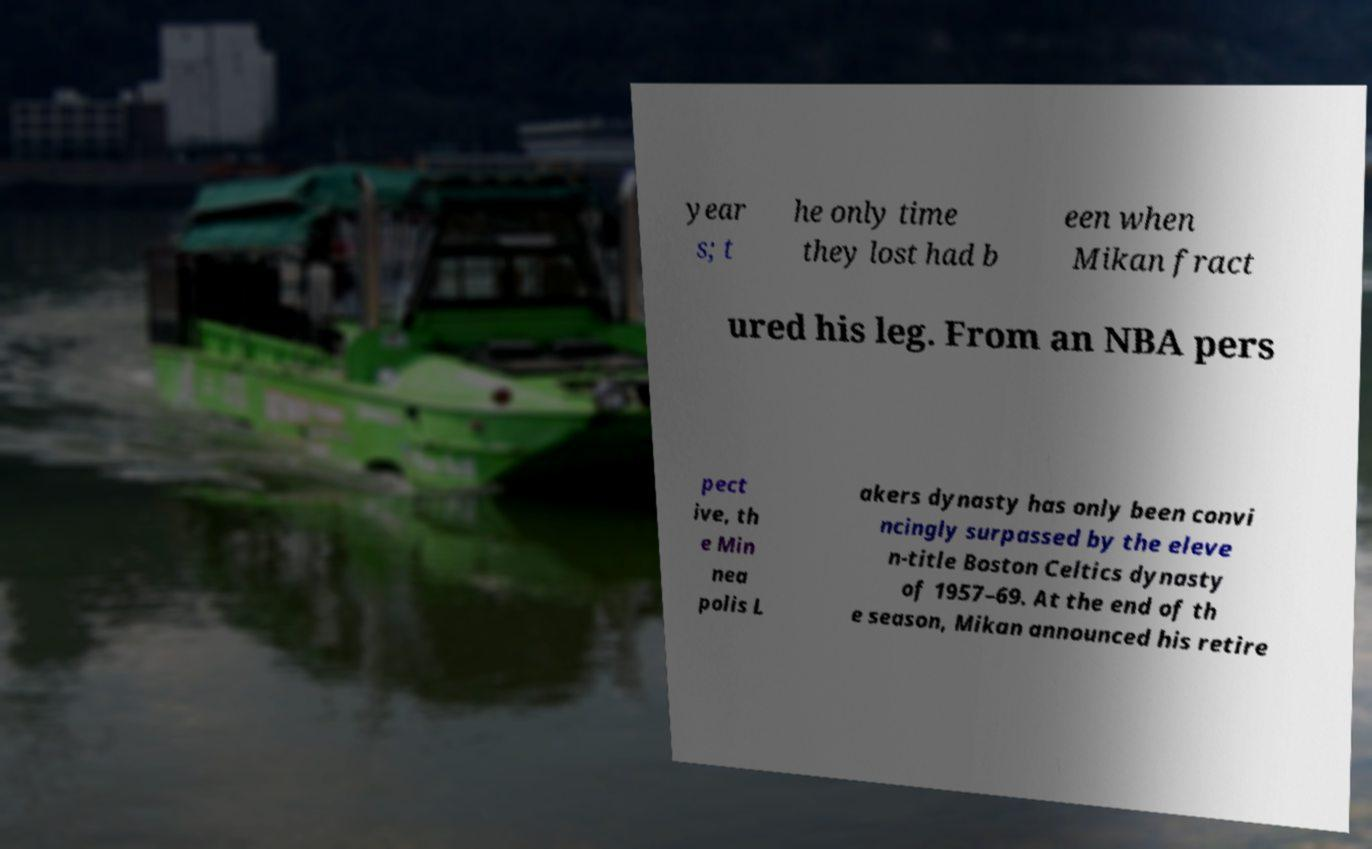Please read and relay the text visible in this image. What does it say? year s; t he only time they lost had b een when Mikan fract ured his leg. From an NBA pers pect ive, th e Min nea polis L akers dynasty has only been convi ncingly surpassed by the eleve n-title Boston Celtics dynasty of 1957–69. At the end of th e season, Mikan announced his retire 